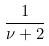Convert formula to latex. <formula><loc_0><loc_0><loc_500><loc_500>\frac { 1 } { \nu + 2 }</formula> 